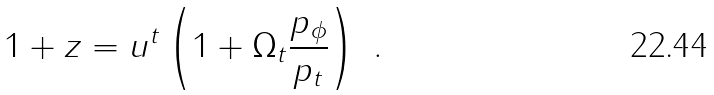Convert formula to latex. <formula><loc_0><loc_0><loc_500><loc_500>1 + z = u ^ { t } \left ( 1 + \Omega _ { t } \frac { p _ { \phi } } { p _ { t } } \right ) \ .</formula> 